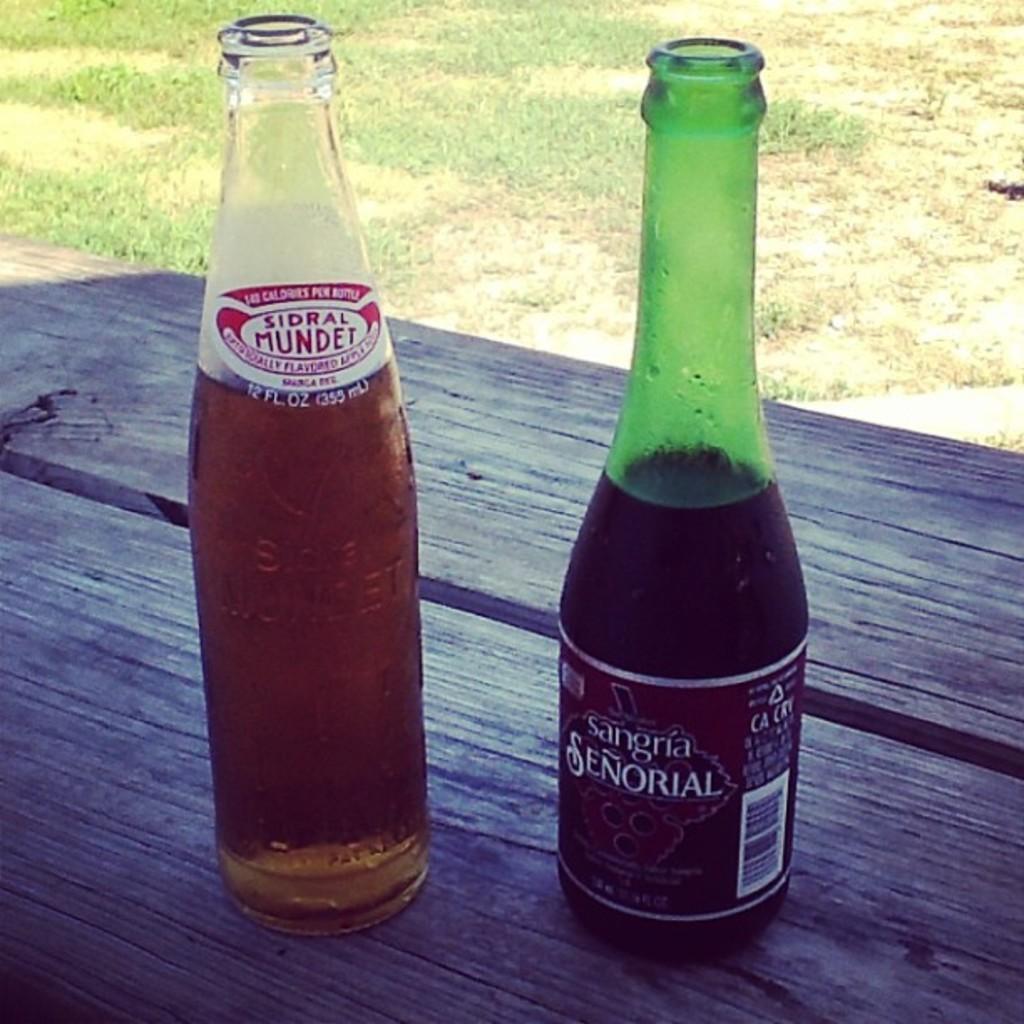Could you give a brief overview of what you see in this image? In this image, There is a table which is in black color and on that table there are two bottles and in the background there is grass. 